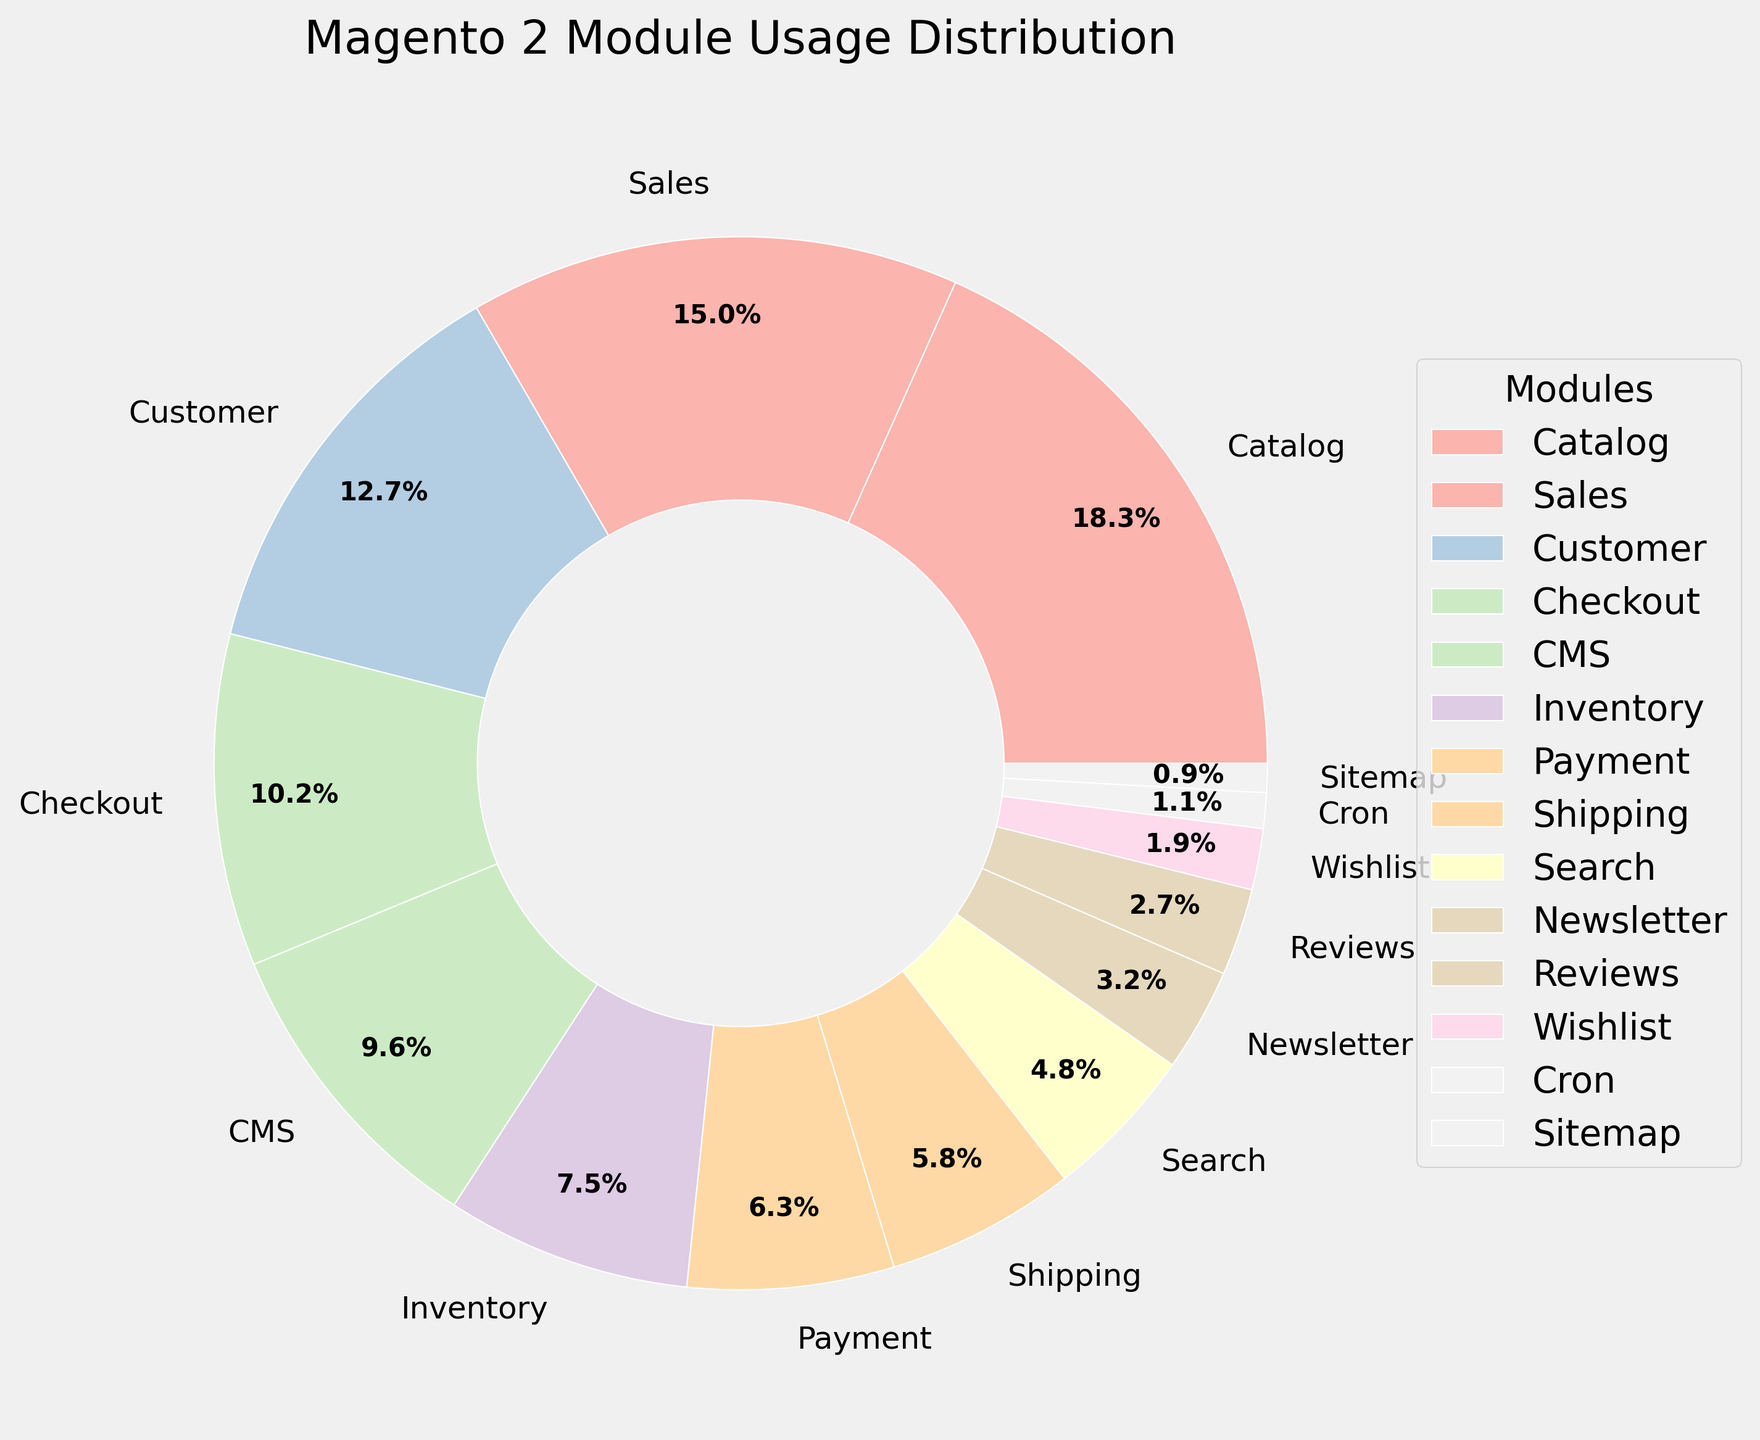What's the most used module in the pie chart? The pie chart shows the module names and their respective usage percentages. The largest slice corresponds to the 'Catalog' module with 18.5%.
Answer: Catalog Which module has a higher usage percentage: Payment or Shipping? By reading the pie chart, the 'Payment' module has a usage percentage of 6.4%, whereas the 'Shipping' module has a usage percentage of 5.9%. Thus, the 'Payment' module has a higher usage percentage.
Answer: Payment What is the combined usage percentage of the Customer and Checkout modules? Refer to the pie chart to find the usage percentages: Customer (12.8%) and Checkout (10.3%). Add these two values: 12.8% + 10.3% = 23.1%.
Answer: 23.1% How many modules have a usage percentage less than 5%? Identify the modules from the pie chart with usage percentages under 5%: Search (4.8%), Newsletter (3.2%), Reviews (2.7%), Wishlist (1.9%), Cron (1.1%), and Sitemap (0.9%). There are 6 such modules.
Answer: 6 Which module has the smallest usage percentage, and what is it? The module with the smallest slice on the pie chart is 'Sitemap' with a usage percentage of 0.9%.
Answer: Sitemap, 0.9% Is the usage percentage of the CMS module greater than twice the usage percentage of the Wishlist module? The CMS module has a usage percentage of 9.7%, and the Wishlist module has 1.9%. Twice the Wishlist usage is 1.9% * 2 = 3.8%. Since 9.7% > 3.8%, the CMS module usage is indeed greater than twice the Wishlist usage.
Answer: Yes What is the sum of the usage percentages of the three smallest modules? The three smallest modules in the pie chart are Cron (1.1%), Sitemap (0.9%), and Wishlist (1.9%). Their sum is 1.1% + 0.9% + 1.9% = 3.9%.
Answer: 3.9% Arrange the modules: Inventory, Payment, and Shipping in descending order based on usage percentages. Use the pie chart to get usage percentages: Inventory (7.6%), Payment (6.4%), and Shipping (5.9%). Arranged in descending order: Inventory, Payment, Shipping.
Answer: Inventory, Payment, Shipping 